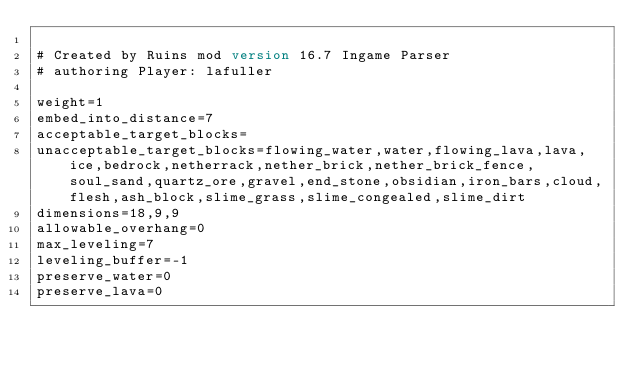Convert code to text. <code><loc_0><loc_0><loc_500><loc_500><_XML_>
# Created by Ruins mod version 16.7 Ingame Parser
# authoring Player: lafuller

weight=1
embed_into_distance=7
acceptable_target_blocks=
unacceptable_target_blocks=flowing_water,water,flowing_lava,lava,ice,bedrock,netherrack,nether_brick,nether_brick_fence,soul_sand,quartz_ore,gravel,end_stone,obsidian,iron_bars,cloud,flesh,ash_block,slime_grass,slime_congealed,slime_dirt
dimensions=18,9,9
allowable_overhang=0
max_leveling=7
leveling_buffer=-1
preserve_water=0
preserve_lava=0
</code> 